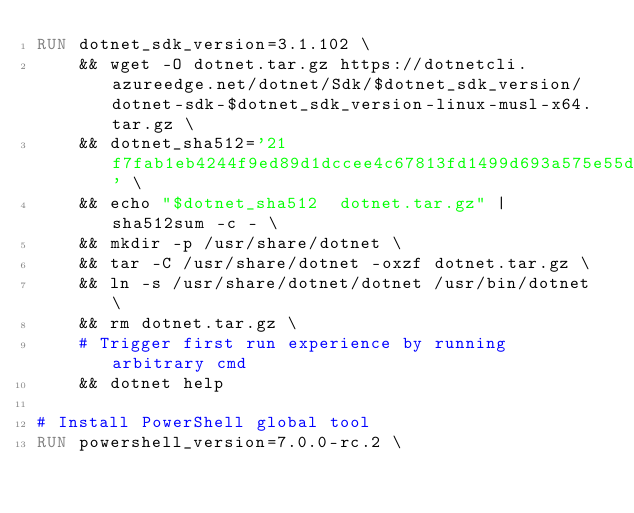<code> <loc_0><loc_0><loc_500><loc_500><_Dockerfile_>RUN dotnet_sdk_version=3.1.102 \
    && wget -O dotnet.tar.gz https://dotnetcli.azureedge.net/dotnet/Sdk/$dotnet_sdk_version/dotnet-sdk-$dotnet_sdk_version-linux-musl-x64.tar.gz \
    && dotnet_sha512='21f7fab1eb4244f9ed89d1dccee4c67813fd1499d693a575e55d077049df14468905803ada814c5fc99ddfec748df453ae3d9d4b1206f9b1089044191e99a57d' \
    && echo "$dotnet_sha512  dotnet.tar.gz" | sha512sum -c - \
    && mkdir -p /usr/share/dotnet \
    && tar -C /usr/share/dotnet -oxzf dotnet.tar.gz \
    && ln -s /usr/share/dotnet/dotnet /usr/bin/dotnet \
    && rm dotnet.tar.gz \
    # Trigger first run experience by running arbitrary cmd
    && dotnet help

# Install PowerShell global tool
RUN powershell_version=7.0.0-rc.2 \</code> 